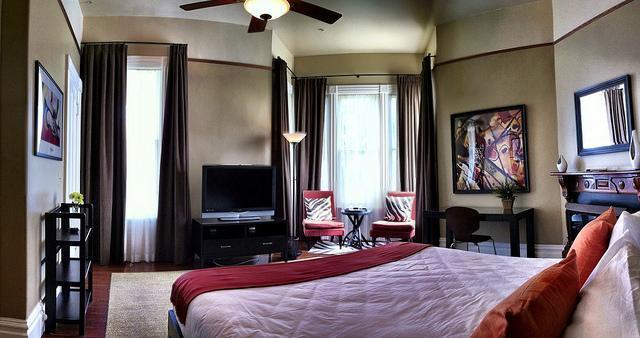How many mirrors are in the room?
Give a very brief answer. 1. How many tvs can you see?
Give a very brief answer. 2. How many beds can you see?
Give a very brief answer. 1. 